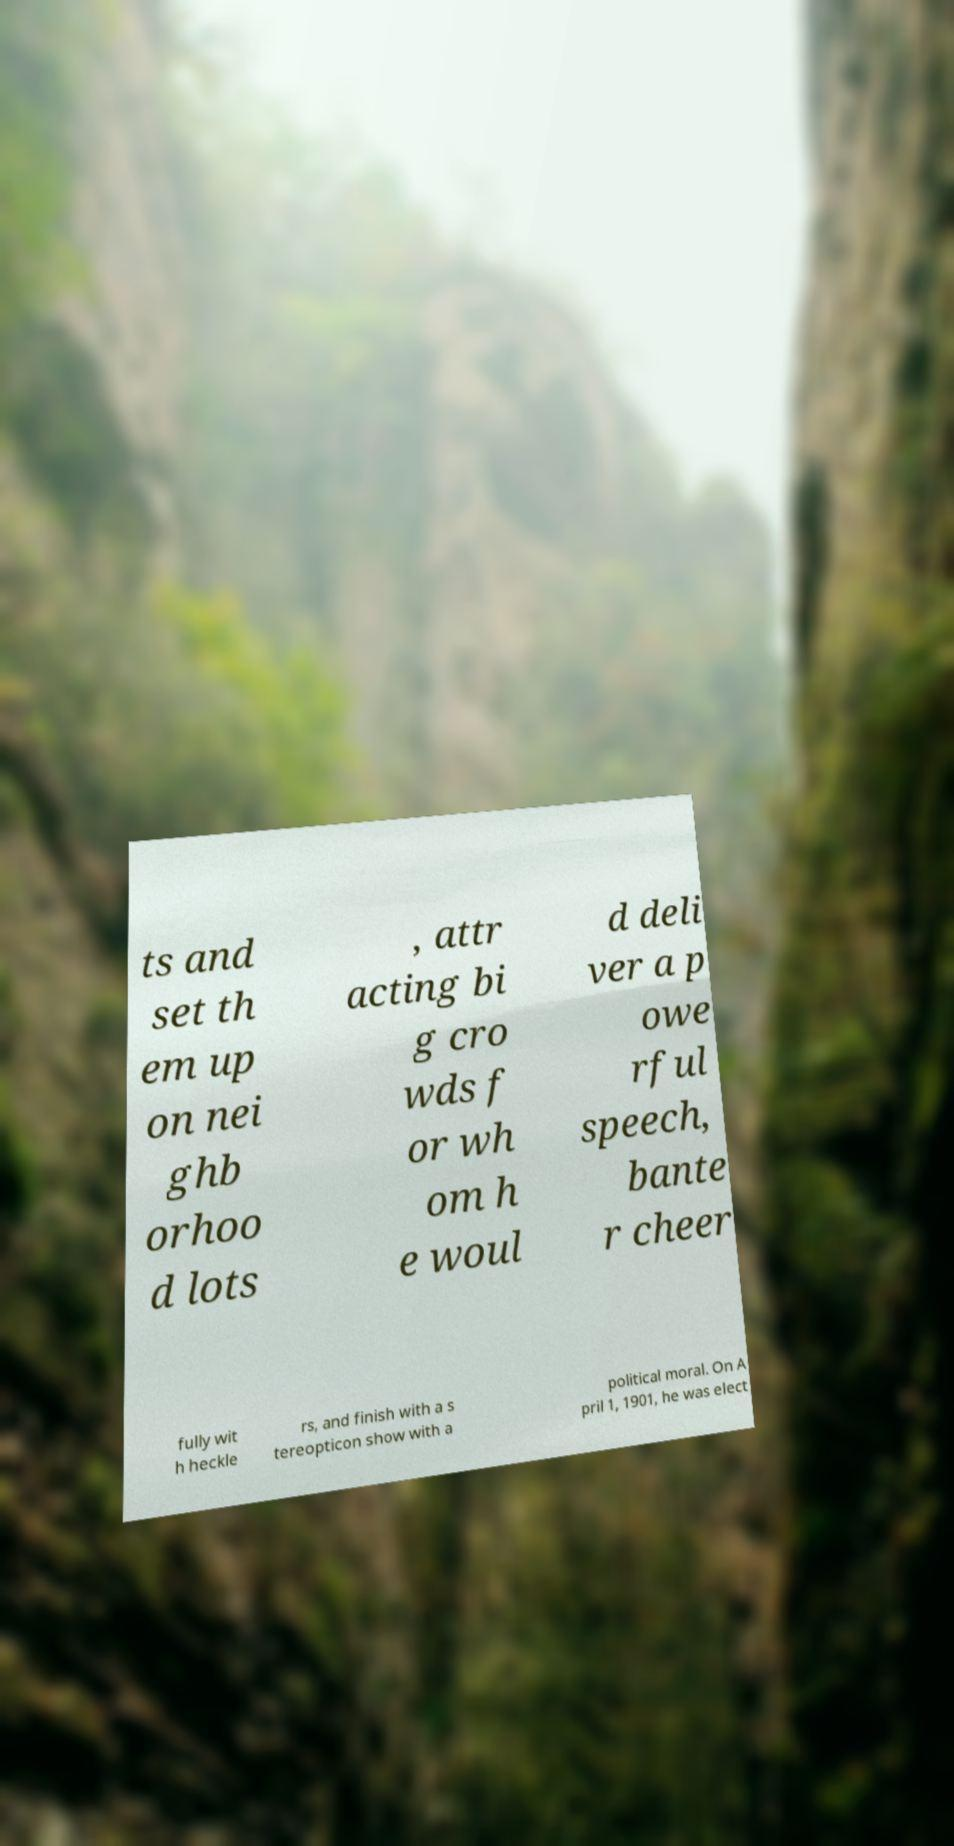I need the written content from this picture converted into text. Can you do that? ts and set th em up on nei ghb orhoo d lots , attr acting bi g cro wds f or wh om h e woul d deli ver a p owe rful speech, bante r cheer fully wit h heckle rs, and finish with a s tereopticon show with a political moral. On A pril 1, 1901, he was elect 